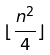Convert formula to latex. <formula><loc_0><loc_0><loc_500><loc_500>\lfloor \frac { n ^ { 2 } } { 4 } \rfloor</formula> 